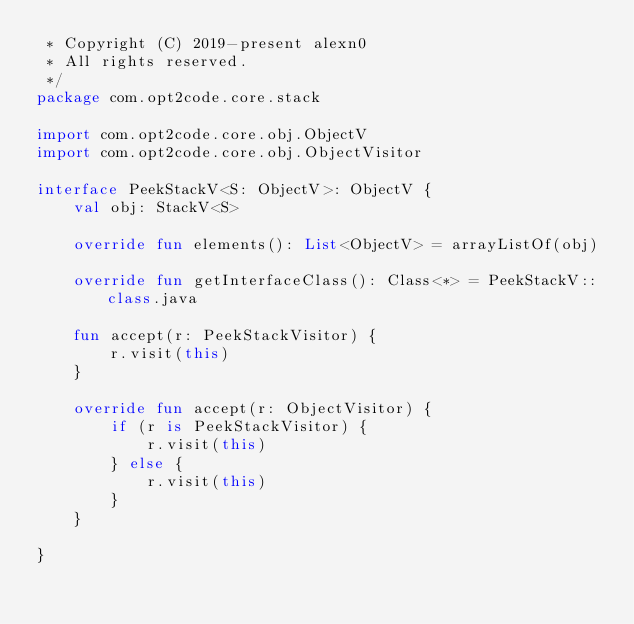Convert code to text. <code><loc_0><loc_0><loc_500><loc_500><_Kotlin_> * Copyright (C) 2019-present alexn0
 * All rights reserved.
 */
package com.opt2code.core.stack

import com.opt2code.core.obj.ObjectV
import com.opt2code.core.obj.ObjectVisitor

interface PeekStackV<S: ObjectV>: ObjectV {
    val obj: StackV<S>

    override fun elements(): List<ObjectV> = arrayListOf(obj)

    override fun getInterfaceClass(): Class<*> = PeekStackV::class.java

    fun accept(r: PeekStackVisitor) {
        r.visit(this)
    }

    override fun accept(r: ObjectVisitor) {
        if (r is PeekStackVisitor) {
            r.visit(this)
        } else {
            r.visit(this)
        }
    }

}</code> 